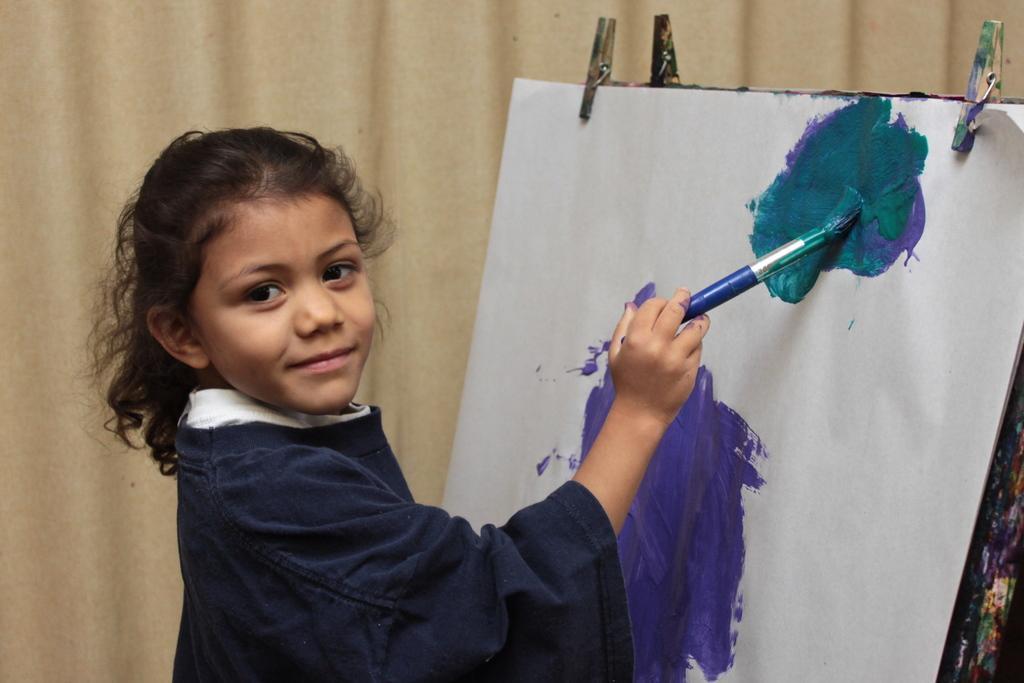Can you describe this image briefly? In the foreground of this image, there is a girl in blue dress painting on a painting board and in the background, there is a cream curtain. 